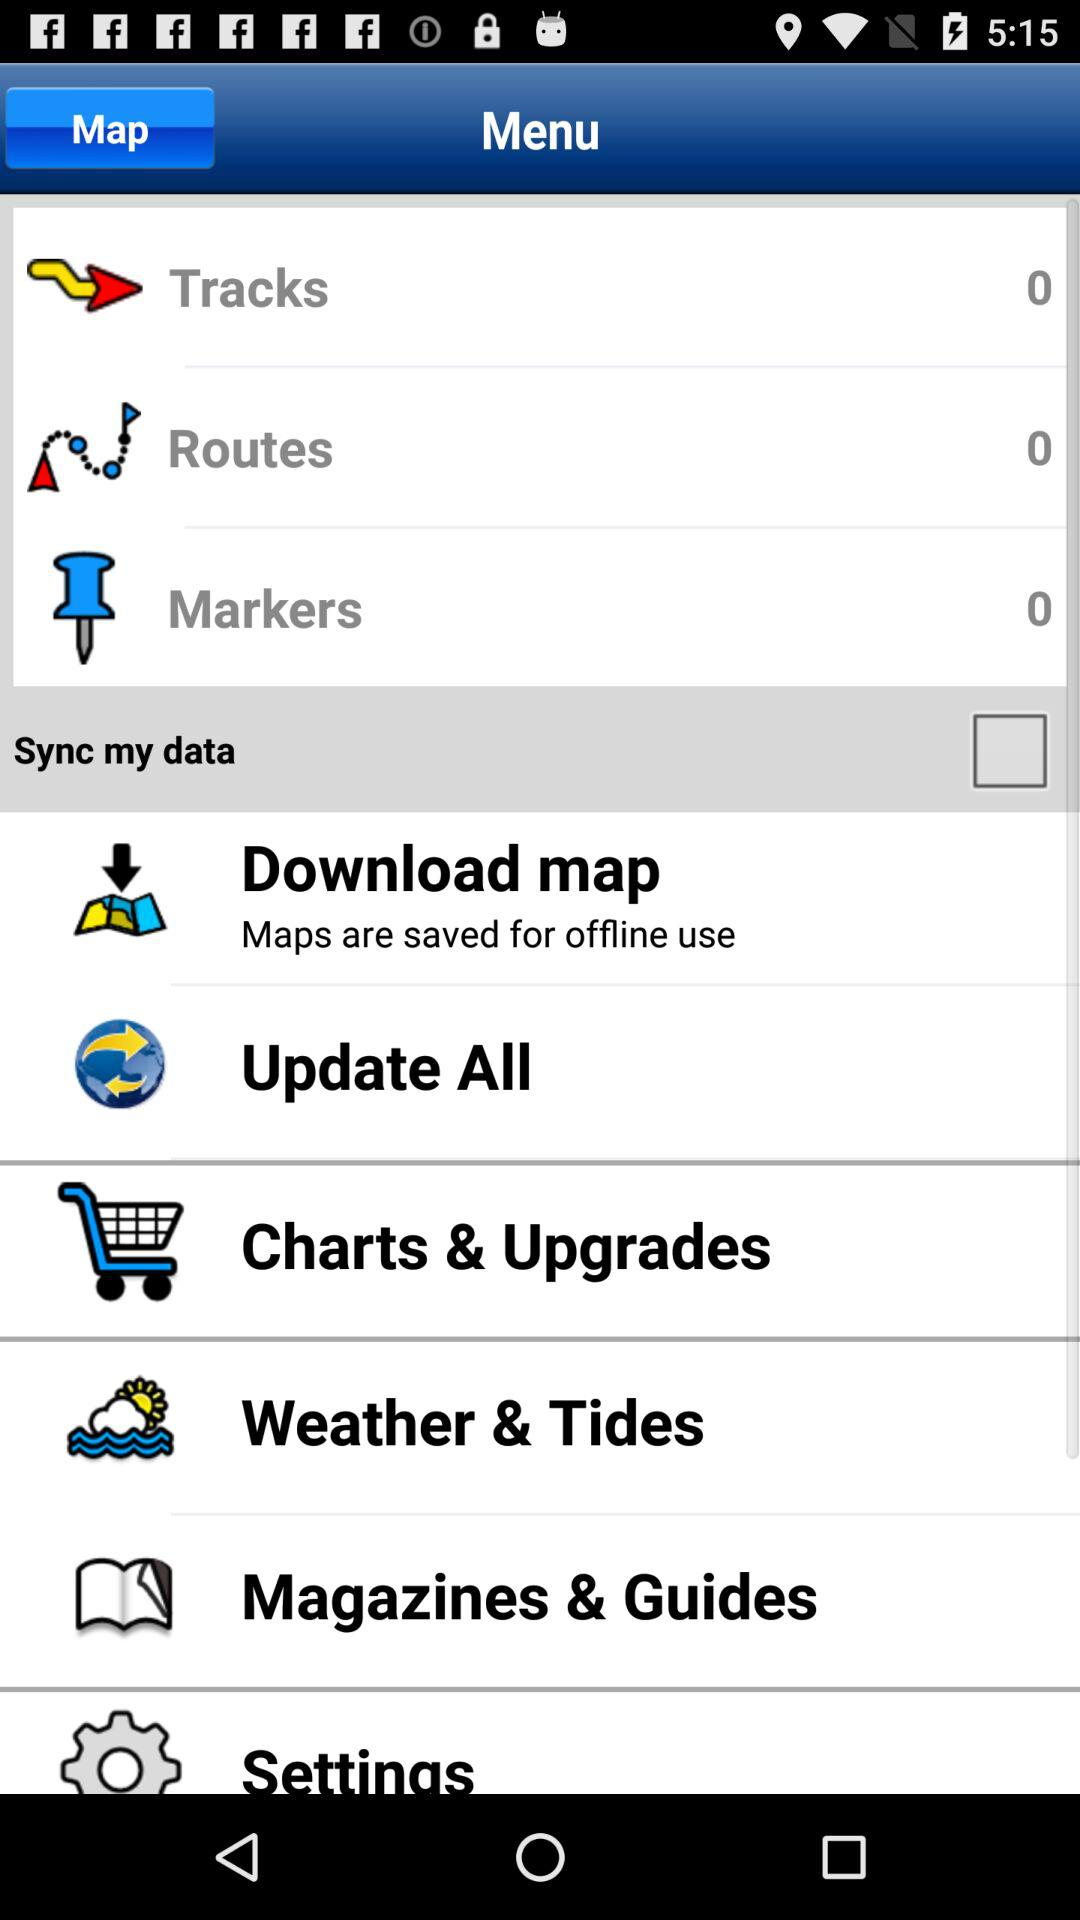How many tracks are there? There are 0 tracks. 